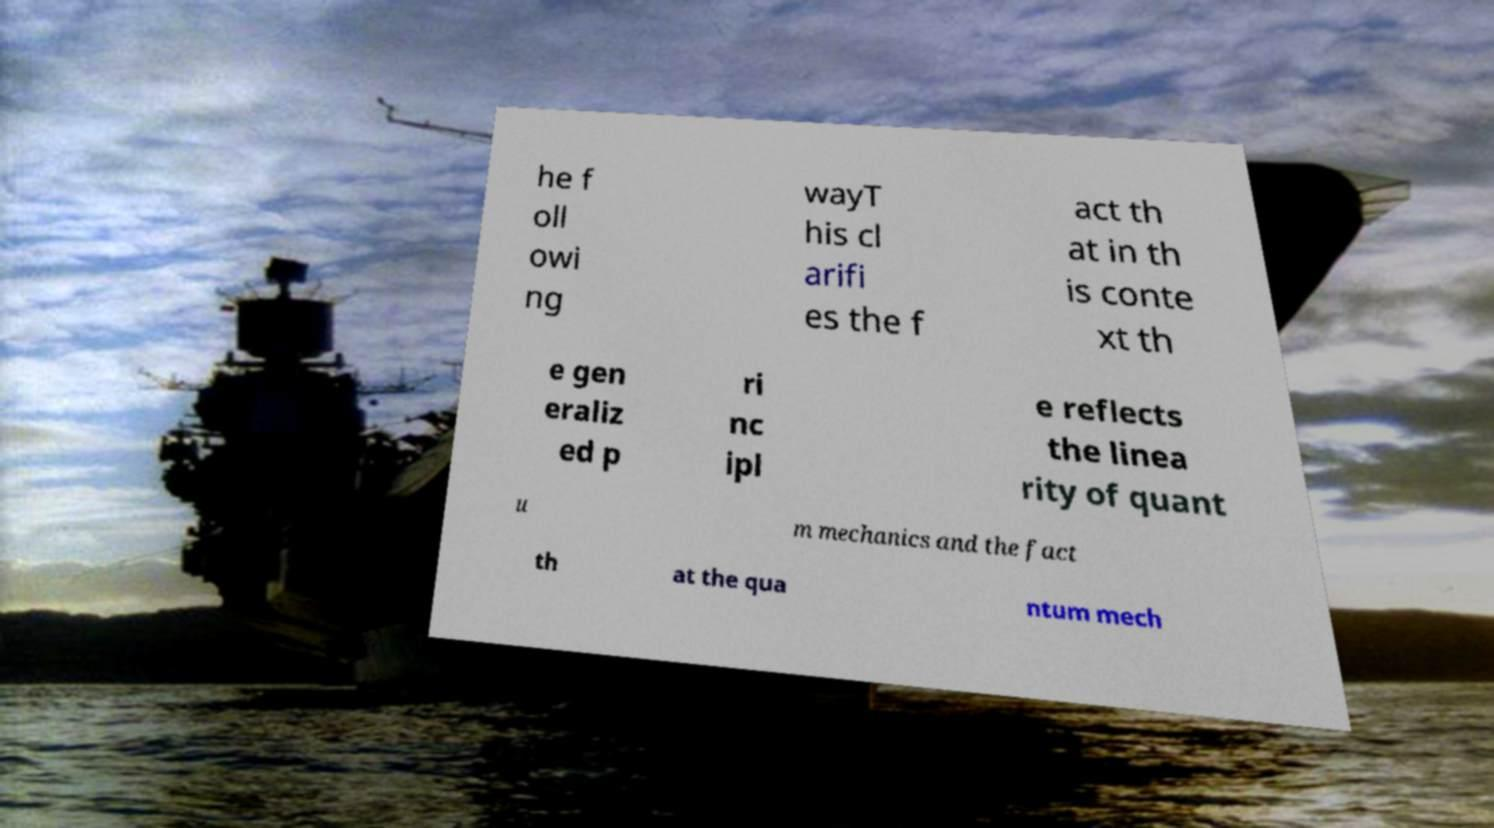Please read and relay the text visible in this image. What does it say? he f oll owi ng wayT his cl arifi es the f act th at in th is conte xt th e gen eraliz ed p ri nc ipl e reflects the linea rity of quant u m mechanics and the fact th at the qua ntum mech 